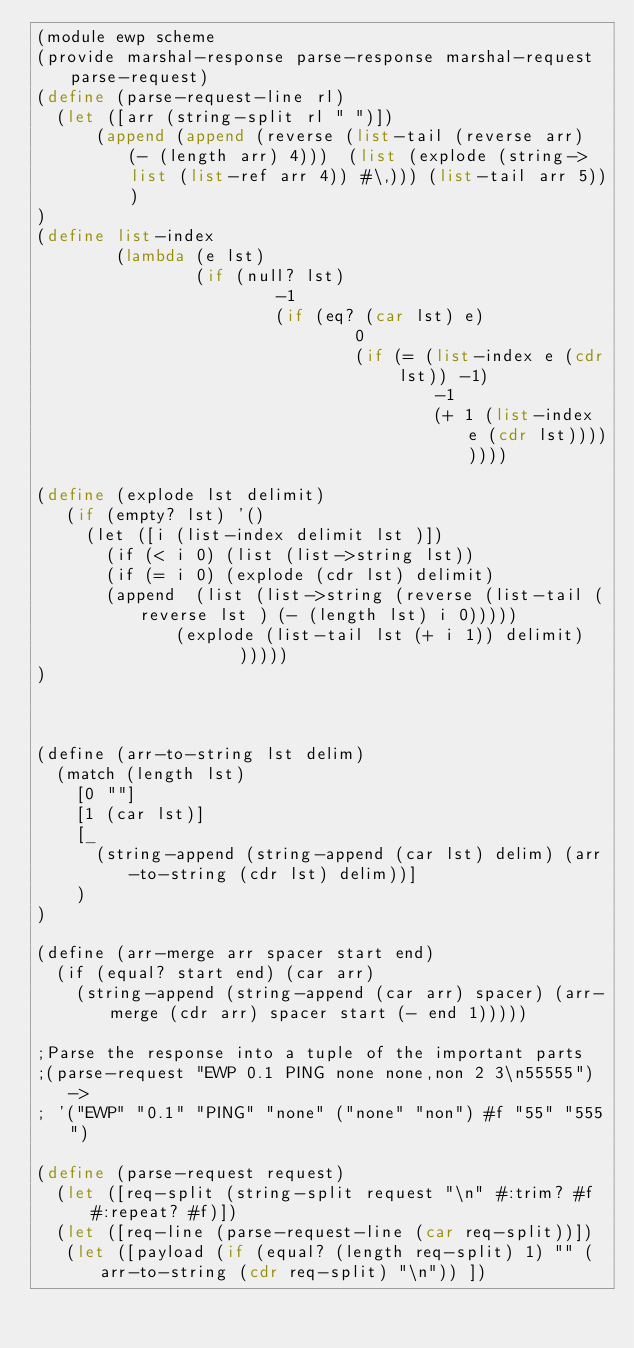<code> <loc_0><loc_0><loc_500><loc_500><_Scheme_>(module ewp scheme
(provide marshal-response parse-response marshal-request parse-request)
(define (parse-request-line rl)
  (let ([arr (string-split rl " ")])
      (append (append (reverse (list-tail (reverse arr) (- (length arr) 4)))  (list (explode (string->list (list-ref arr 4)) #\,))) (list-tail arr 5)))
)
(define list-index
        (lambda (e lst)
                (if (null? lst)
                        -1
                        (if (eq? (car lst) e)
                                0
                                (if (= (list-index e (cdr lst)) -1) 
                                        -1
                                        (+ 1 (list-index e (cdr lst))))))))

(define (explode lst delimit)
   (if (empty? lst) '()
     (let ([i (list-index delimit lst )])
       (if (< i 0) (list (list->string lst))
       (if (= i 0) (explode (cdr lst) delimit)
       (append  (list (list->string (reverse (list-tail (reverse lst ) (- (length lst) i 0)))))
              (explode (list-tail lst (+ i 1)) delimit)    )))))
)



(define (arr-to-string lst delim)
  (match (length lst)
    [0 ""]
    [1 (car lst)]
    [_
      (string-append (string-append (car lst) delim) (arr-to-string (cdr lst) delim))]
    )
)

(define (arr-merge arr spacer start end)
  (if (equal? start end) (car arr)
    (string-append (string-append (car arr) spacer) (arr-merge (cdr arr) spacer start (- end 1)))))

;Parse the response into a tuple of the important parts
;(parse-request "EWP 0.1 PING none none,non 2 3\n55555") ->
; '("EWP" "0.1" "PING" "none" ("none" "non") #f "55" "555")
  
(define (parse-request request)
  (let ([req-split (string-split request "\n" #:trim? #f #:repeat? #f)])
  (let ([req-line (parse-request-line (car req-split))])
   (let ([payload (if (equal? (length req-split) 1) "" (arr-to-string (cdr req-split) "\n")) ])</code> 